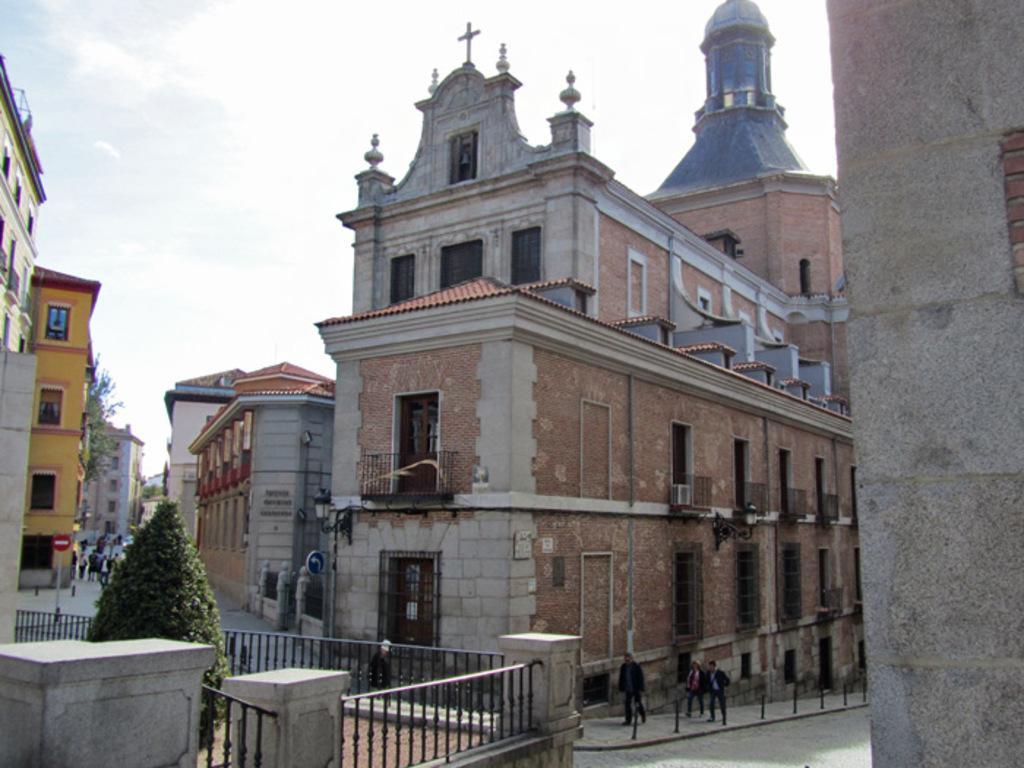Could you give a brief overview of what you see in this image? In this picture we can see there are buildings and trees. At the bottom of the image, there are iron grilles. Behind the iron grilles, there are three persons walking on the walkway and there are lane poles. On the right side of the image, there is a wall. Behind the buildings, there is the sky. 